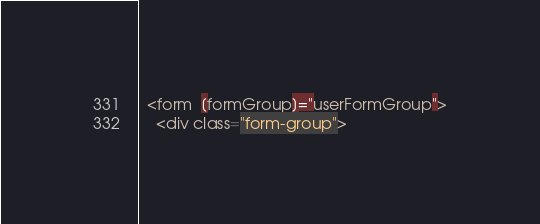<code> <loc_0><loc_0><loc_500><loc_500><_HTML_>  <form  [formGroup]="userFormGroup">
    <div class="form-group"></code> 